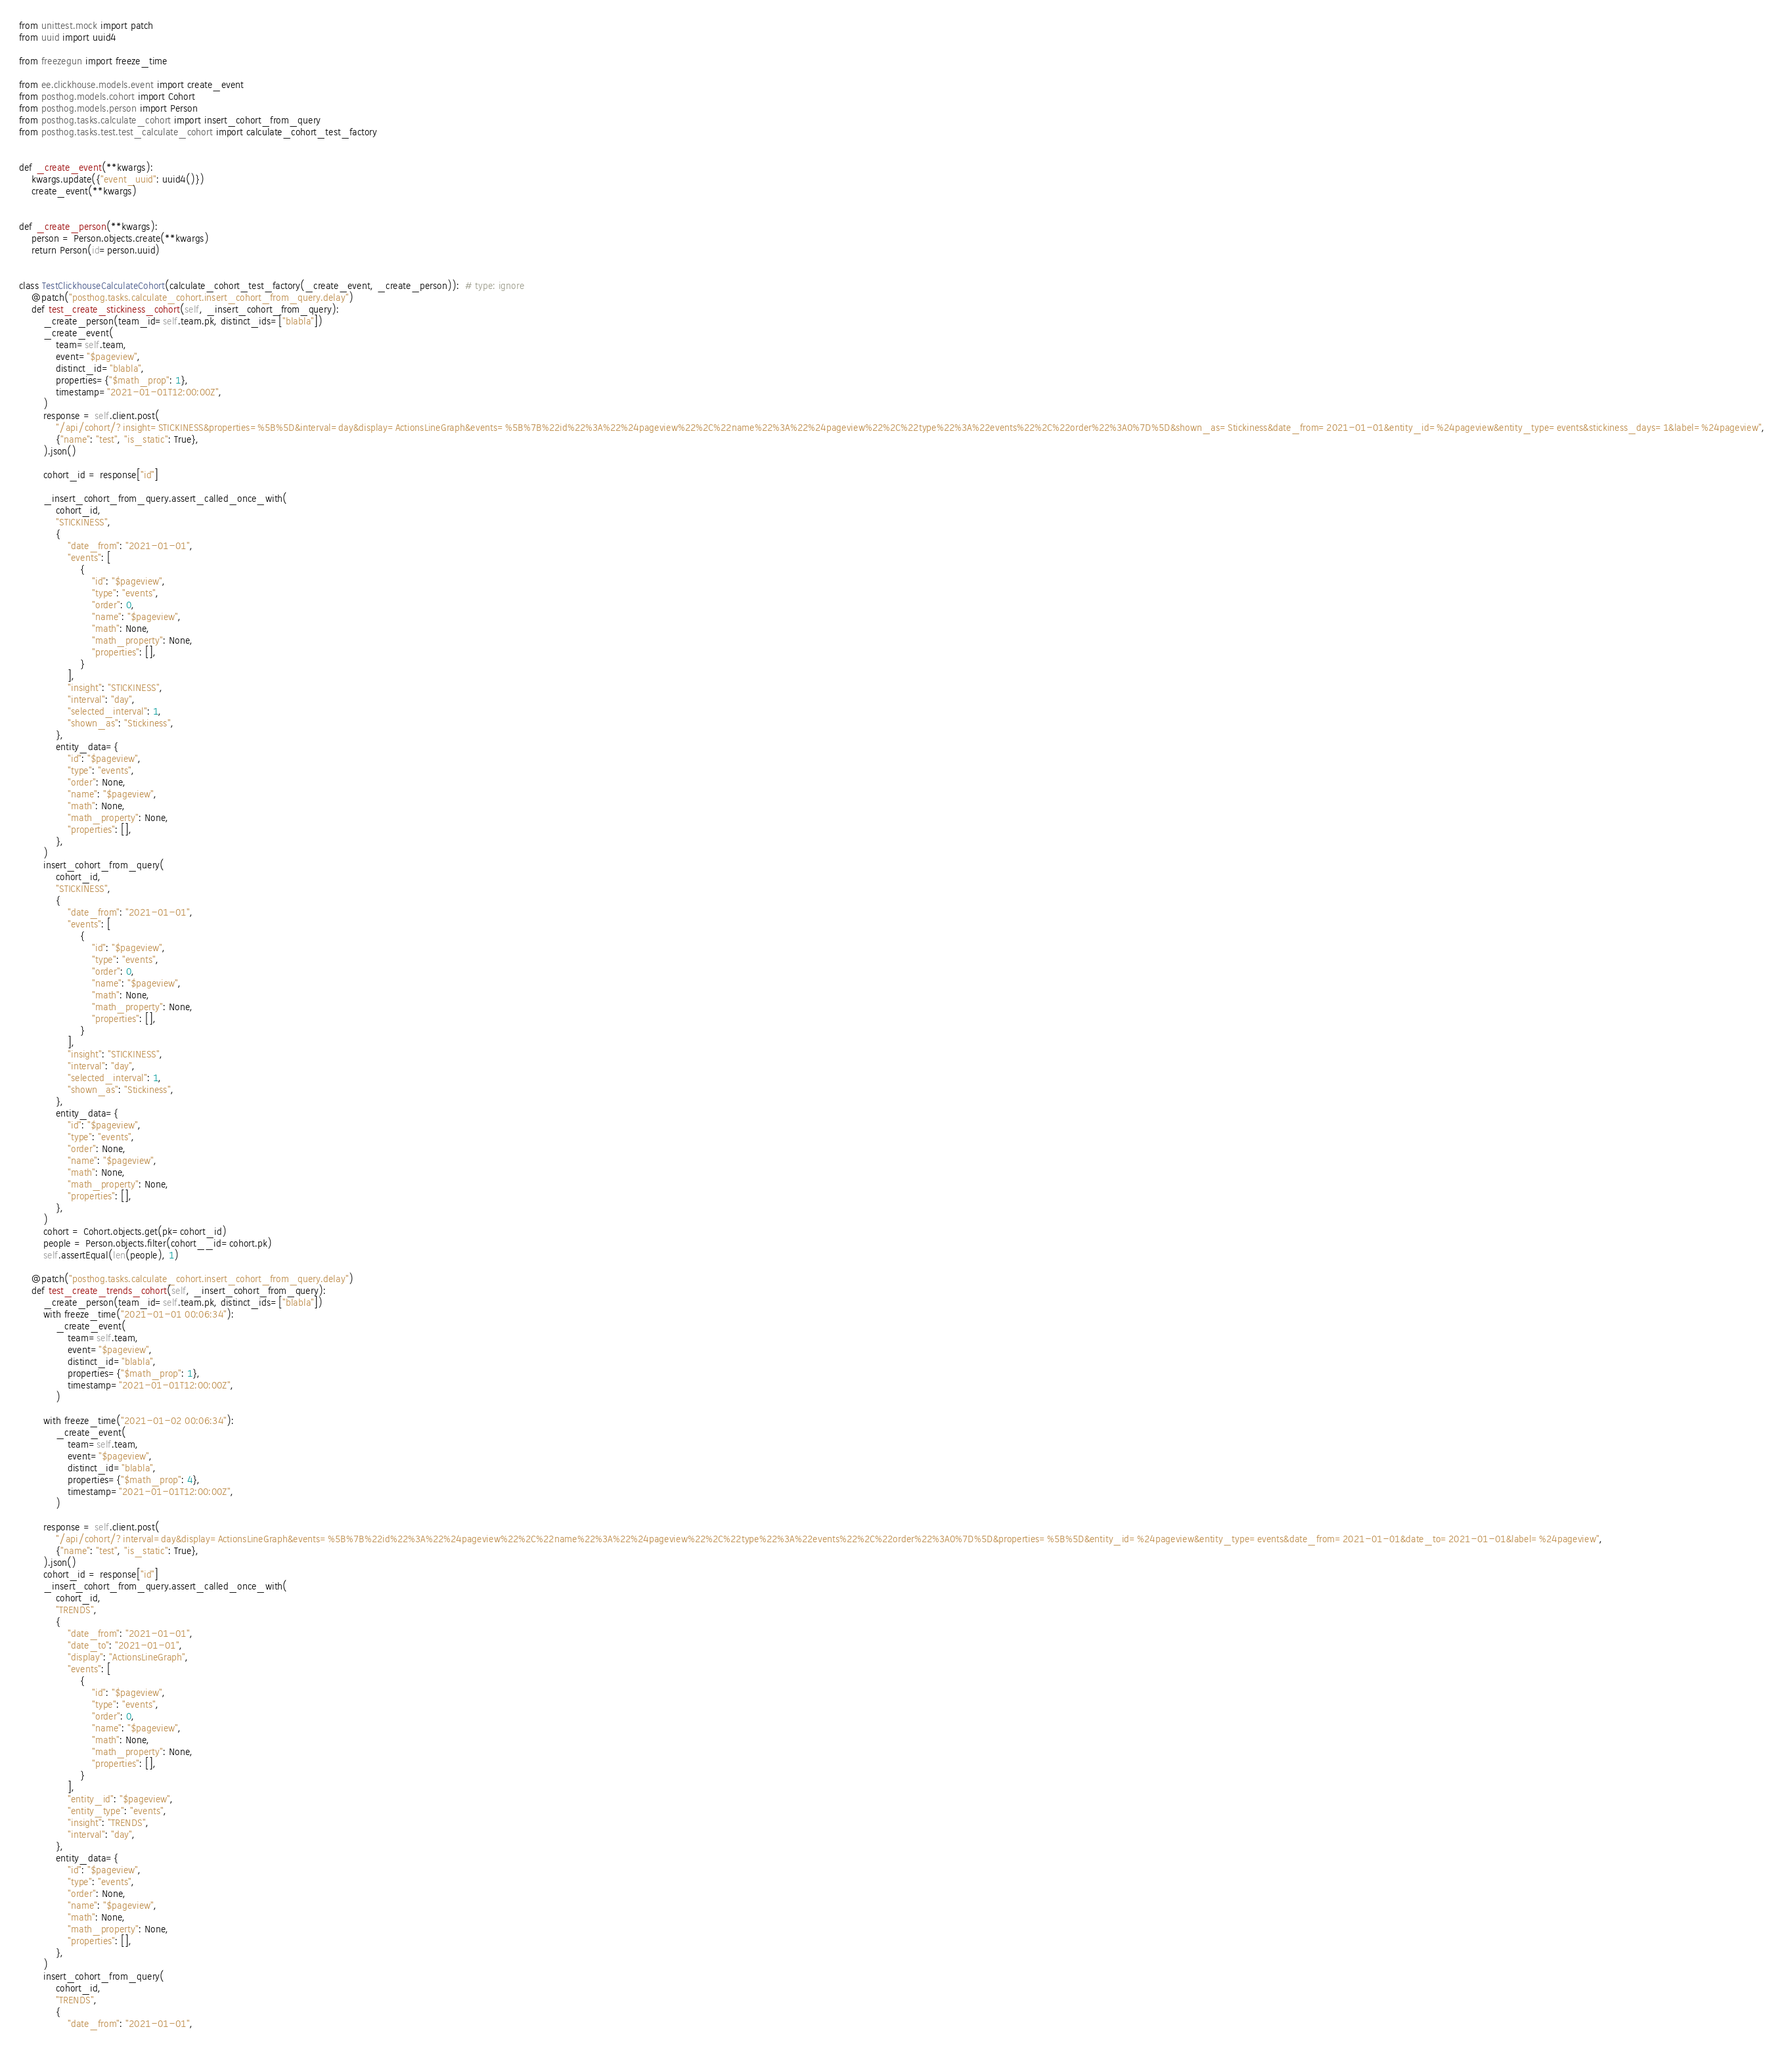Convert code to text. <code><loc_0><loc_0><loc_500><loc_500><_Python_>from unittest.mock import patch
from uuid import uuid4

from freezegun import freeze_time

from ee.clickhouse.models.event import create_event
from posthog.models.cohort import Cohort
from posthog.models.person import Person
from posthog.tasks.calculate_cohort import insert_cohort_from_query
from posthog.tasks.test.test_calculate_cohort import calculate_cohort_test_factory


def _create_event(**kwargs):
    kwargs.update({"event_uuid": uuid4()})
    create_event(**kwargs)


def _create_person(**kwargs):
    person = Person.objects.create(**kwargs)
    return Person(id=person.uuid)


class TestClickhouseCalculateCohort(calculate_cohort_test_factory(_create_event, _create_person)):  # type: ignore
    @patch("posthog.tasks.calculate_cohort.insert_cohort_from_query.delay")
    def test_create_stickiness_cohort(self, _insert_cohort_from_query):
        _create_person(team_id=self.team.pk, distinct_ids=["blabla"])
        _create_event(
            team=self.team,
            event="$pageview",
            distinct_id="blabla",
            properties={"$math_prop": 1},
            timestamp="2021-01-01T12:00:00Z",
        )
        response = self.client.post(
            "/api/cohort/?insight=STICKINESS&properties=%5B%5D&interval=day&display=ActionsLineGraph&events=%5B%7B%22id%22%3A%22%24pageview%22%2C%22name%22%3A%22%24pageview%22%2C%22type%22%3A%22events%22%2C%22order%22%3A0%7D%5D&shown_as=Stickiness&date_from=2021-01-01&entity_id=%24pageview&entity_type=events&stickiness_days=1&label=%24pageview",
            {"name": "test", "is_static": True},
        ).json()

        cohort_id = response["id"]

        _insert_cohort_from_query.assert_called_once_with(
            cohort_id,
            "STICKINESS",
            {
                "date_from": "2021-01-01",
                "events": [
                    {
                        "id": "$pageview",
                        "type": "events",
                        "order": 0,
                        "name": "$pageview",
                        "math": None,
                        "math_property": None,
                        "properties": [],
                    }
                ],
                "insight": "STICKINESS",
                "interval": "day",
                "selected_interval": 1,
                "shown_as": "Stickiness",
            },
            entity_data={
                "id": "$pageview",
                "type": "events",
                "order": None,
                "name": "$pageview",
                "math": None,
                "math_property": None,
                "properties": [],
            },
        )
        insert_cohort_from_query(
            cohort_id,
            "STICKINESS",
            {
                "date_from": "2021-01-01",
                "events": [
                    {
                        "id": "$pageview",
                        "type": "events",
                        "order": 0,
                        "name": "$pageview",
                        "math": None,
                        "math_property": None,
                        "properties": [],
                    }
                ],
                "insight": "STICKINESS",
                "interval": "day",
                "selected_interval": 1,
                "shown_as": "Stickiness",
            },
            entity_data={
                "id": "$pageview",
                "type": "events",
                "order": None,
                "name": "$pageview",
                "math": None,
                "math_property": None,
                "properties": [],
            },
        )
        cohort = Cohort.objects.get(pk=cohort_id)
        people = Person.objects.filter(cohort__id=cohort.pk)
        self.assertEqual(len(people), 1)

    @patch("posthog.tasks.calculate_cohort.insert_cohort_from_query.delay")
    def test_create_trends_cohort(self, _insert_cohort_from_query):
        _create_person(team_id=self.team.pk, distinct_ids=["blabla"])
        with freeze_time("2021-01-01 00:06:34"):
            _create_event(
                team=self.team,
                event="$pageview",
                distinct_id="blabla",
                properties={"$math_prop": 1},
                timestamp="2021-01-01T12:00:00Z",
            )

        with freeze_time("2021-01-02 00:06:34"):
            _create_event(
                team=self.team,
                event="$pageview",
                distinct_id="blabla",
                properties={"$math_prop": 4},
                timestamp="2021-01-01T12:00:00Z",
            )

        response = self.client.post(
            "/api/cohort/?interval=day&display=ActionsLineGraph&events=%5B%7B%22id%22%3A%22%24pageview%22%2C%22name%22%3A%22%24pageview%22%2C%22type%22%3A%22events%22%2C%22order%22%3A0%7D%5D&properties=%5B%5D&entity_id=%24pageview&entity_type=events&date_from=2021-01-01&date_to=2021-01-01&label=%24pageview",
            {"name": "test", "is_static": True},
        ).json()
        cohort_id = response["id"]
        _insert_cohort_from_query.assert_called_once_with(
            cohort_id,
            "TRENDS",
            {
                "date_from": "2021-01-01",
                "date_to": "2021-01-01",
                "display": "ActionsLineGraph",
                "events": [
                    {
                        "id": "$pageview",
                        "type": "events",
                        "order": 0,
                        "name": "$pageview",
                        "math": None,
                        "math_property": None,
                        "properties": [],
                    }
                ],
                "entity_id": "$pageview",
                "entity_type": "events",
                "insight": "TRENDS",
                "interval": "day",
            },
            entity_data={
                "id": "$pageview",
                "type": "events",
                "order": None,
                "name": "$pageview",
                "math": None,
                "math_property": None,
                "properties": [],
            },
        )
        insert_cohort_from_query(
            cohort_id,
            "TRENDS",
            {
                "date_from": "2021-01-01",</code> 